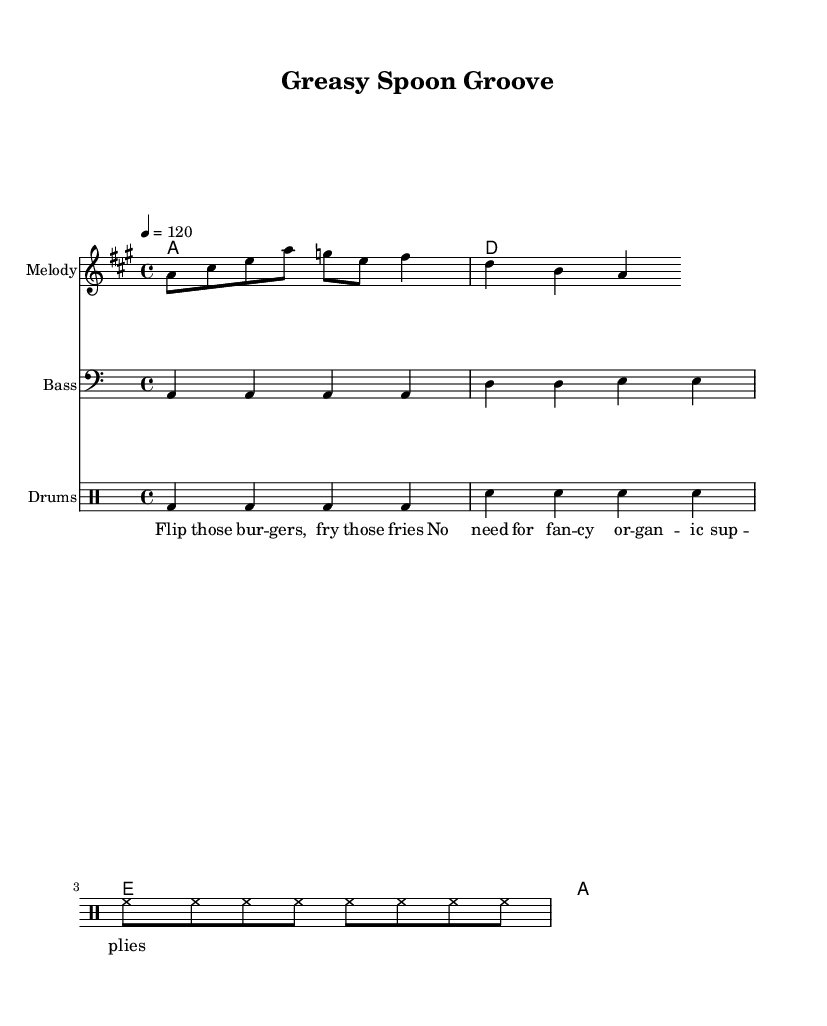What is the key signature of this music? The key signature at the beginning of the sheet music shows two sharps, which indicates that the key is A major.
Answer: A major What is the time signature of this music? The time signature is indicated by the "4/4" marking, which means there are four beats in each measure and the quarter note gets one beat.
Answer: 4/4 What is the tempo marking for this piece? The tempo marking at the top states "4 = 120", indicating that there are 120 beats per minute with the quarter note.
Answer: 120 How many measures are in the melody? By counting the notes in the melody staff, we see there are eight notes which correspond to two measures (each containing four beats), confirming that the melody fits within two measures.
Answer: 2 What type of drum pattern is used in this piece? The combination of bass drum, snare, and hi-hat rhythms shows a classic disco drum groove, typically characterized by a steady four-on-the-floor pattern and syncopated snare hits, which aligns with the characteristics of Disco music.
Answer: Disco groove What phrase summarizes the lyrics? The lyrics provided, "Flip those burgers, fry those fries," capture a casual, fun reference to cooking, showcasing the upbeat and lively theme typical in Disco tracks about food.
Answer: Cooking theme What does the bass line primarily consist of? The bass line contains repeated notes aligned with the root chords of the piece, specifically playing A and D, which are fundamental to the harmonic structure of disco music, emphasizing a strong rhythmic backbeat.
Answer: Repeated notes 